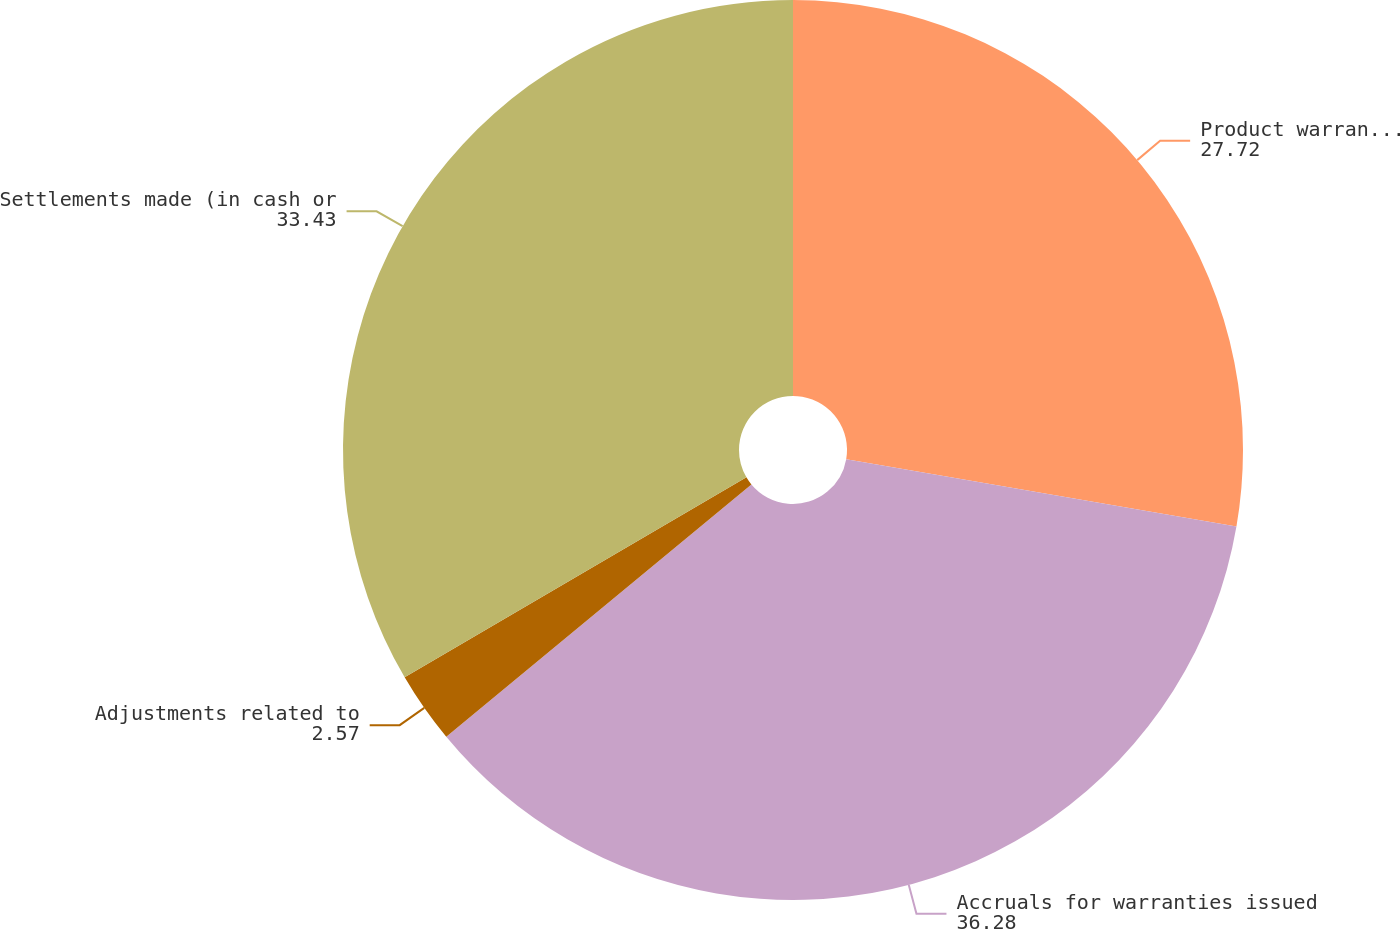Convert chart. <chart><loc_0><loc_0><loc_500><loc_500><pie_chart><fcel>Product warranty liability at<fcel>Accruals for warranties issued<fcel>Adjustments related to<fcel>Settlements made (in cash or<nl><fcel>27.72%<fcel>36.28%<fcel>2.57%<fcel>33.43%<nl></chart> 